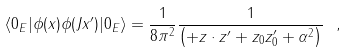Convert formula to latex. <formula><loc_0><loc_0><loc_500><loc_500>\langle { 0 _ { E } } | \phi ( x ) \phi ( J x ^ { \prime } ) | 0 _ { E } \rangle = \frac { 1 } { 8 \pi ^ { 2 } } \frac { 1 } { \left ( + z \cdot z ^ { \prime } + z _ { 0 } z ^ { \prime } _ { 0 } + \alpha ^ { 2 } \right ) } \ ,</formula> 